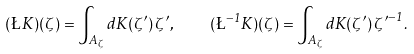<formula> <loc_0><loc_0><loc_500><loc_500>( \L \, K ) ( \zeta ) = \int _ { A _ { \zeta } } d K ( \zeta ^ { \prime } ) \, \zeta ^ { \prime } , \quad ( \L ^ { - 1 } K ) ( \zeta ) = \int _ { A _ { \zeta } } d K ( \zeta ^ { \prime } ) \, { \zeta ^ { \prime } } ^ { - 1 } .</formula> 